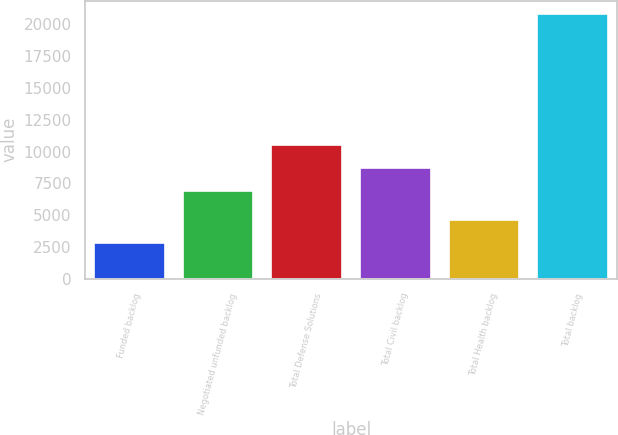Convert chart to OTSL. <chart><loc_0><loc_0><loc_500><loc_500><bar_chart><fcel>Funded backlog<fcel>Negotiated unfunded backlog<fcel>Total Defense Solutions<fcel>Total Civil backlog<fcel>Total Health backlog<fcel>Total backlog<nl><fcel>2811<fcel>6891<fcel>10495.2<fcel>8693.1<fcel>4613.1<fcel>20832<nl></chart> 